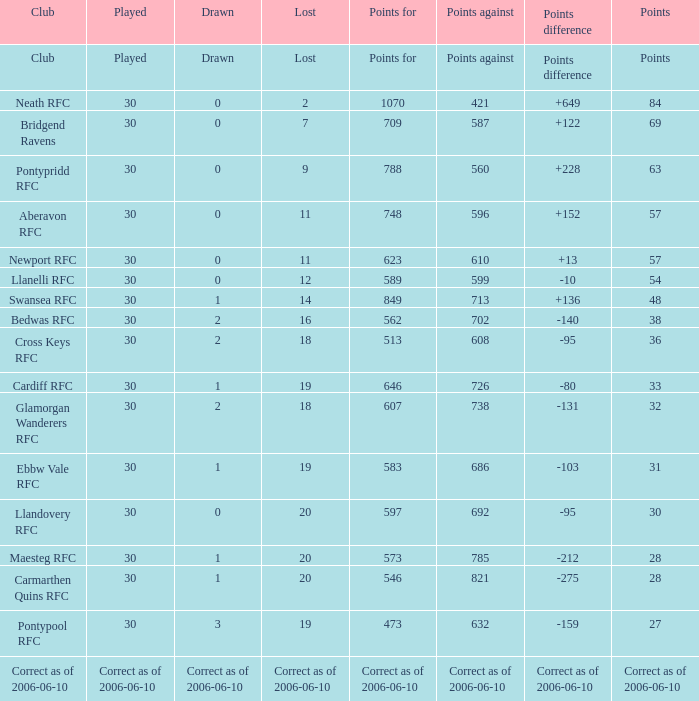What is the points amount when points for stands at "562"? 38.0. 